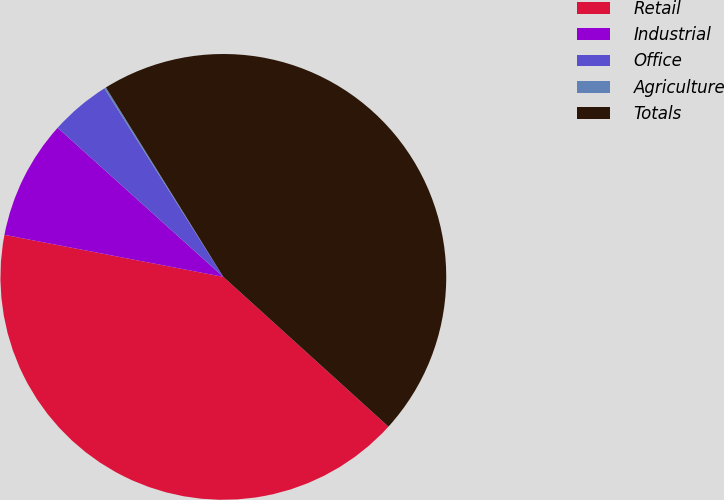<chart> <loc_0><loc_0><loc_500><loc_500><pie_chart><fcel>Retail<fcel>Industrial<fcel>Office<fcel>Agriculture<fcel>Totals<nl><fcel>41.29%<fcel>8.64%<fcel>4.38%<fcel>0.12%<fcel>45.55%<nl></chart> 